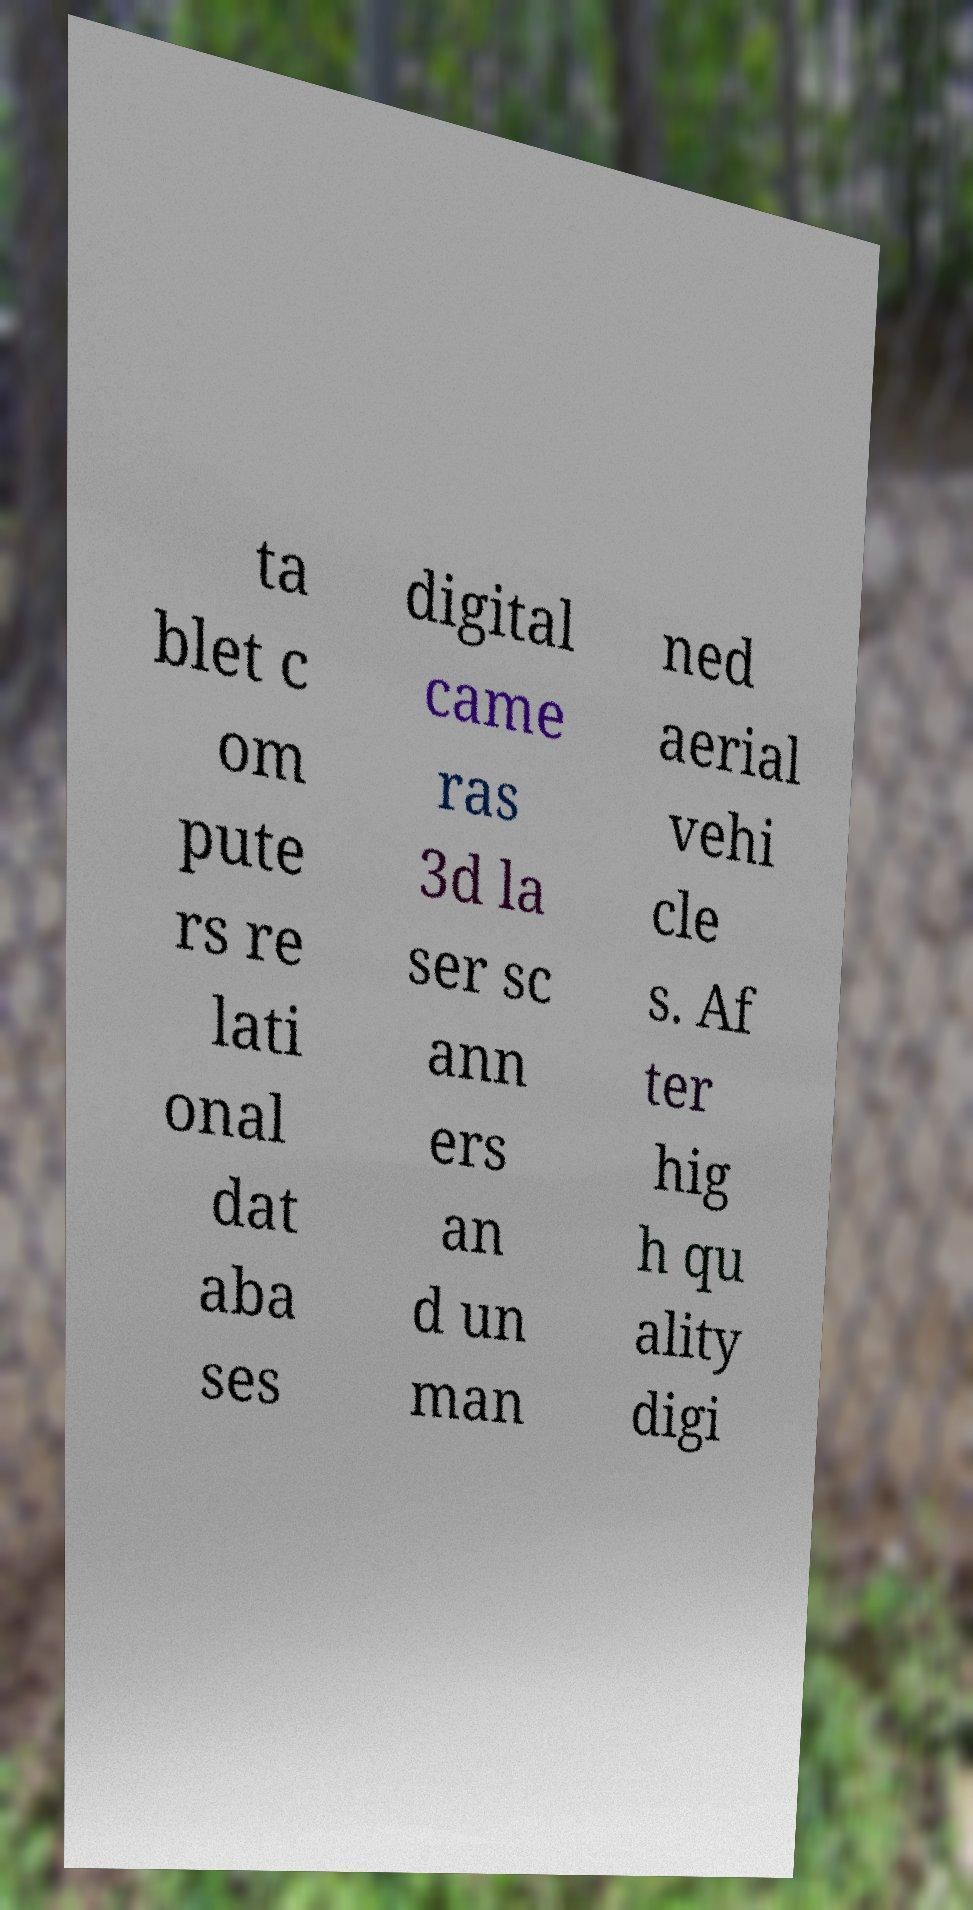I need the written content from this picture converted into text. Can you do that? ta blet c om pute rs re lati onal dat aba ses digital came ras 3d la ser sc ann ers an d un man ned aerial vehi cle s. Af ter hig h qu ality digi 